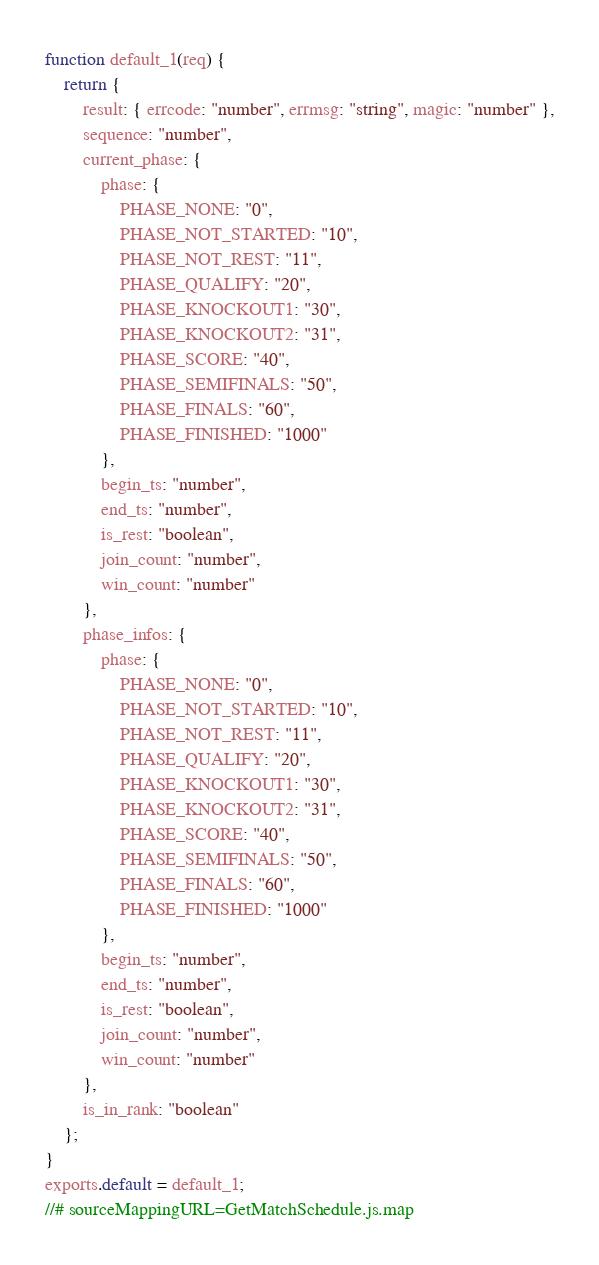Convert code to text. <code><loc_0><loc_0><loc_500><loc_500><_JavaScript_>function default_1(req) {
    return {
        result: { errcode: "number", errmsg: "string", magic: "number" },
        sequence: "number",
        current_phase: {
            phase: {
                PHASE_NONE: "0",
                PHASE_NOT_STARTED: "10",
                PHASE_NOT_REST: "11",
                PHASE_QUALIFY: "20",
                PHASE_KNOCKOUT1: "30",
                PHASE_KNOCKOUT2: "31",
                PHASE_SCORE: "40",
                PHASE_SEMIFINALS: "50",
                PHASE_FINALS: "60",
                PHASE_FINISHED: "1000"
            },
            begin_ts: "number",
            end_ts: "number",
            is_rest: "boolean",
            join_count: "number",
            win_count: "number"
        },
        phase_infos: {
            phase: {
                PHASE_NONE: "0",
                PHASE_NOT_STARTED: "10",
                PHASE_NOT_REST: "11",
                PHASE_QUALIFY: "20",
                PHASE_KNOCKOUT1: "30",
                PHASE_KNOCKOUT2: "31",
                PHASE_SCORE: "40",
                PHASE_SEMIFINALS: "50",
                PHASE_FINALS: "60",
                PHASE_FINISHED: "1000"
            },
            begin_ts: "number",
            end_ts: "number",
            is_rest: "boolean",
            join_count: "number",
            win_count: "number"
        },
        is_in_rank: "boolean"
    };
}
exports.default = default_1;
//# sourceMappingURL=GetMatchSchedule.js.map</code> 